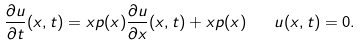<formula> <loc_0><loc_0><loc_500><loc_500>\frac { \partial u } { \partial t } ( x , t ) = x p ( x ) \frac { \partial u } { \partial x } ( x , t ) + x p ( x ) \quad u ( x , t ) = 0 .</formula> 